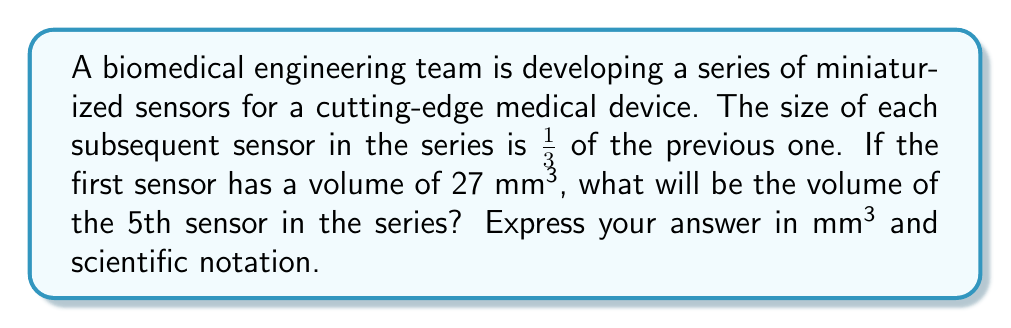What is the answer to this math problem? Let's approach this step-by-step:

1) We're dealing with a geometric sequence where each term is $\frac{1}{3}$ of the previous term.

2) The general formula for a geometric sequence is:

   $$a_n = a_1 \cdot r^{n-1}$$

   Where:
   $a_n$ is the nth term
   $a_1$ is the first term
   $r$ is the common ratio
   $n$ is the position of the term

3) In this case:
   $a_1 = 27$ mm³ (volume of the first sensor)
   $r = \frac{1}{3}$ (each subsequent sensor is $\frac{1}{3}$ of the previous)
   $n = 5$ (we're looking for the 5th sensor)

4) Let's substitute these values into our formula:

   $$a_5 = 27 \cdot (\frac{1}{3})^{5-1}$$

5) Simplify the exponent:

   $$a_5 = 27 \cdot (\frac{1}{3})^4$$

6) Calculate $(\frac{1}{3})^4$:

   $$(\frac{1}{3})^4 = \frac{1}{81}$$

7) Now our equation looks like:

   $$a_5 = 27 \cdot \frac{1}{81}$$

8) Simplify:

   $$a_5 = \frac{27}{81} = \frac{1}{3} = 0.3333...$$

9) Therefore, the volume of the 5th sensor is $\frac{1}{3}$ mm³ or 0.3333... mm³

10) In scientific notation, this is $3.333... \times 10^{-1}$ mm³
Answer: $3.333 \times 10^{-1}$ mm³ 